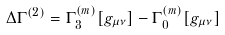<formula> <loc_0><loc_0><loc_500><loc_500>\Delta \Gamma ^ { ( 2 ) } = \Gamma _ { 3 } ^ { ( m ) } [ g _ { \mu \nu } ] - \Gamma _ { 0 } ^ { ( m ) } [ g _ { \mu \nu } ]</formula> 